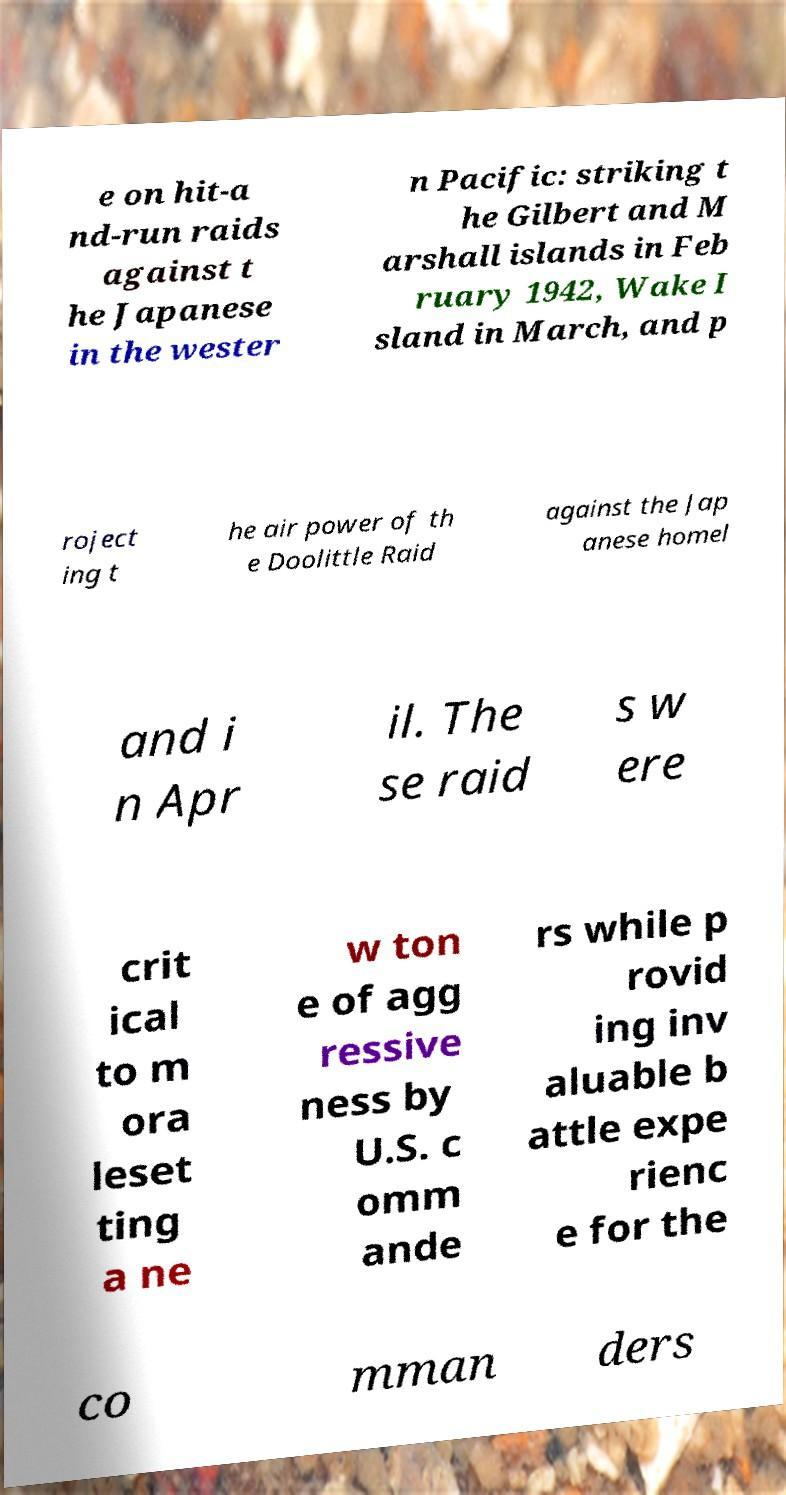Can you accurately transcribe the text from the provided image for me? e on hit-a nd-run raids against t he Japanese in the wester n Pacific: striking t he Gilbert and M arshall islands in Feb ruary 1942, Wake I sland in March, and p roject ing t he air power of th e Doolittle Raid against the Jap anese homel and i n Apr il. The se raid s w ere crit ical to m ora leset ting a ne w ton e of agg ressive ness by U.S. c omm ande rs while p rovid ing inv aluable b attle expe rienc e for the co mman ders 